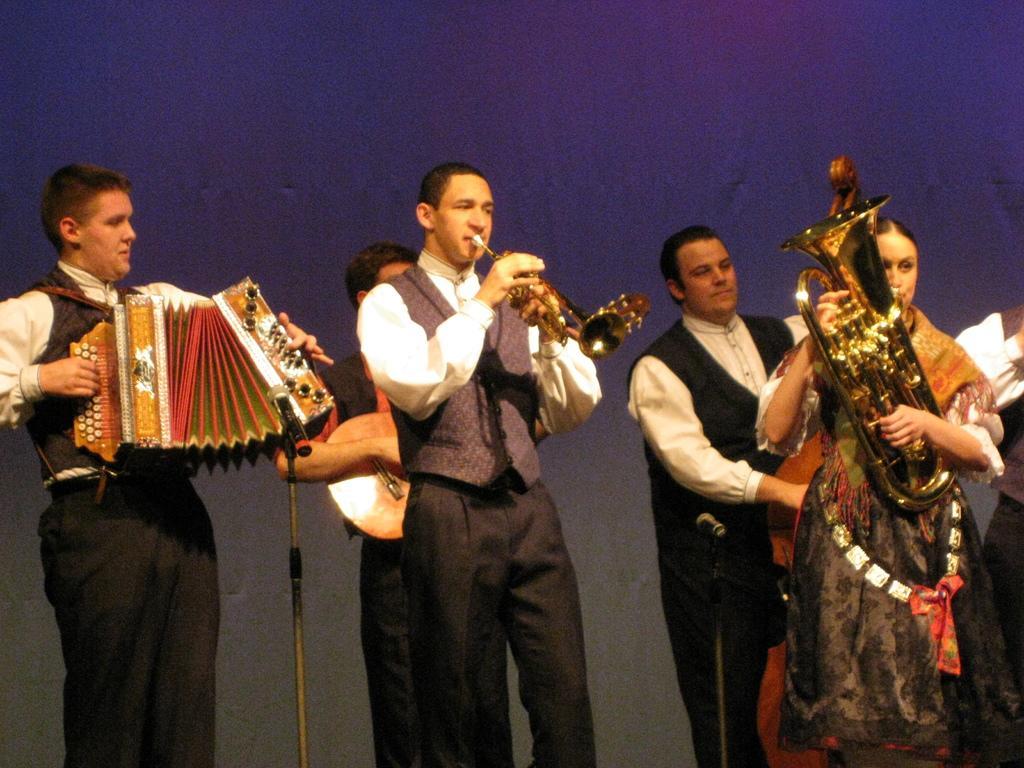Please provide a concise description of this image. In the center of the image we can see people standing and playing musical instruments. At the bottom there is a mic placed on the stand. 